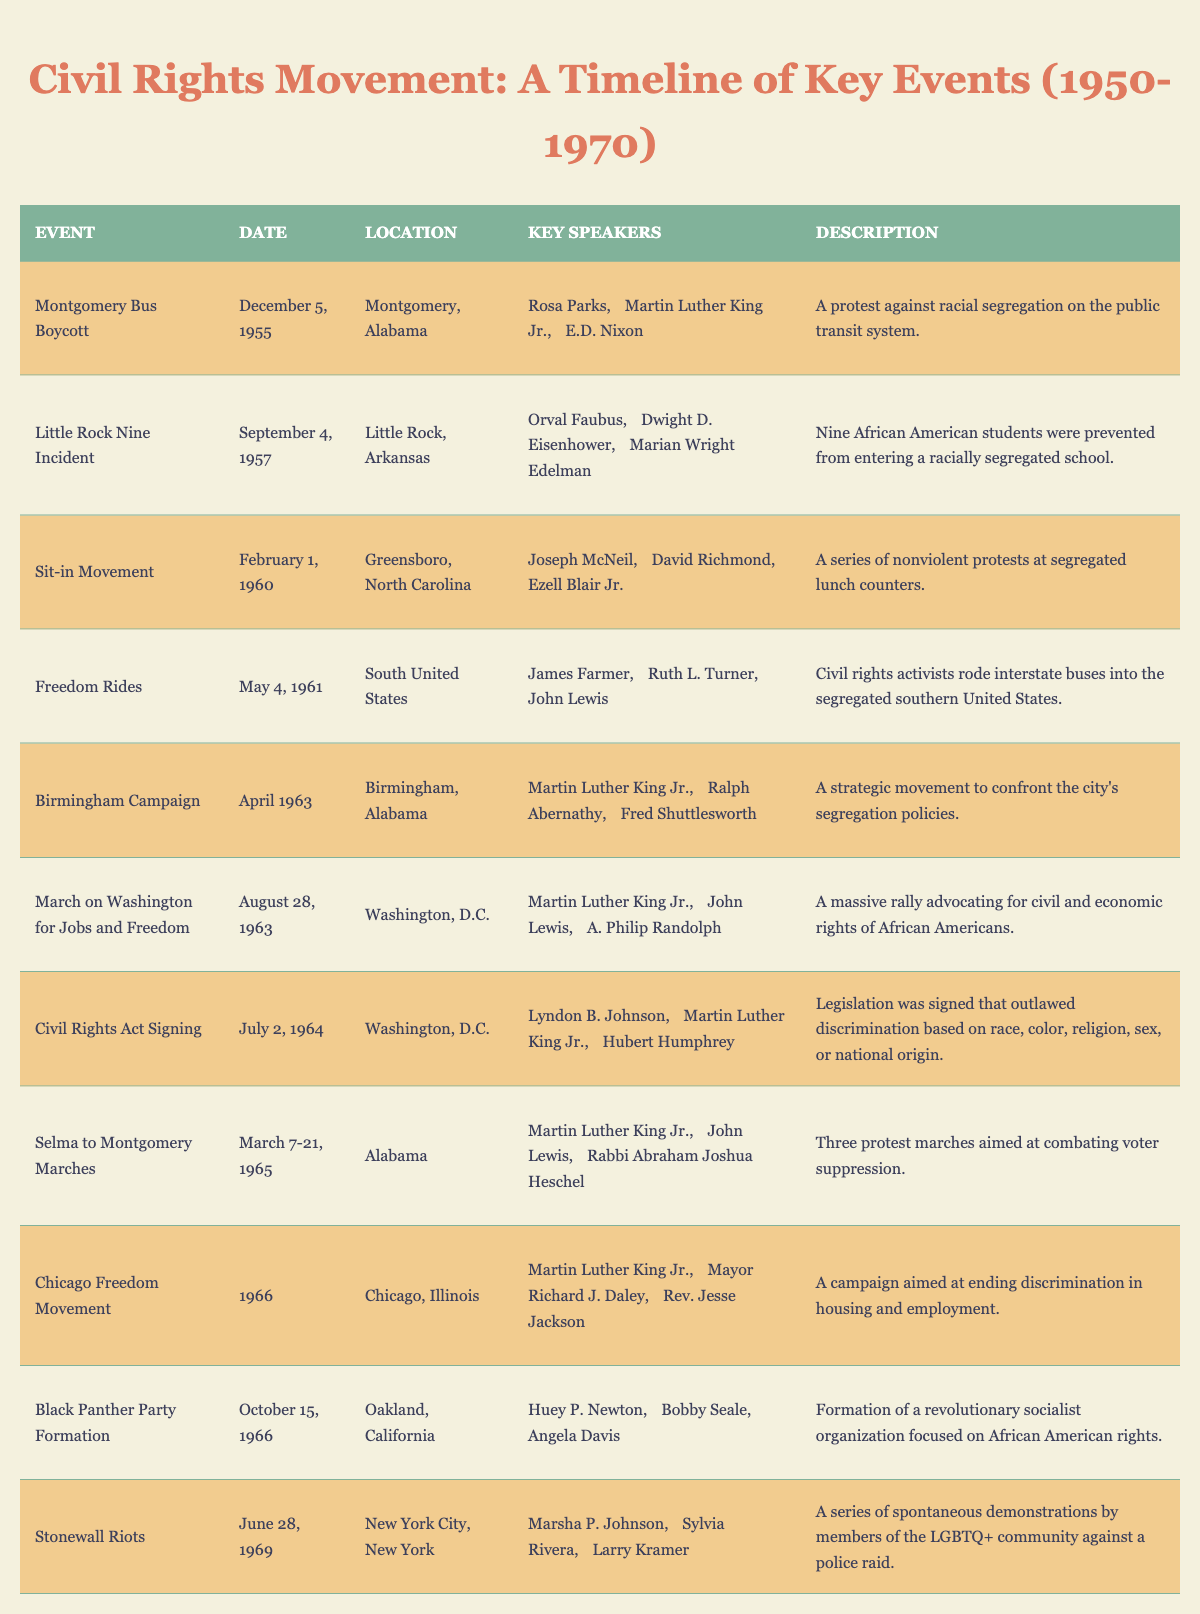What event took place on December 5, 1955? The table indicates that the Montgomery Bus Boycott occurred on December 5, 1955.
Answer: Montgomery Bus Boycott Who were the key speakers at the March on Washington for Jobs and Freedom? The key speakers listed for the March on Washington for Jobs and Freedom are Martin Luther King Jr., John Lewis, and A. Philip Randolph.
Answer: Martin Luther King Jr., John Lewis, A. Philip Randolph Was the Civil Rights Act Signing held in Montgomery, Alabama? The table shows that the Civil Rights Act Signing took place in Washington, D.C., not Montgomery, Alabama.
Answer: No How many events listed in the table occurred in 1963? The events that occurred in 1963 are the Birmingham Campaign and the March on Washington for Jobs and Freedom, making a total of two events.
Answer: 2 List the events where Martin Luther King Jr. was a key speaker. The events with Martin Luther King Jr. as a key speaker include the Montgomery Bus Boycott, Birmingham Campaign, March on Washington for Jobs and Freedom, Civil Rights Act Signing, Selma to Montgomery Marches, and Chicago Freedom Movement.
Answer: 6 events Which event had the smallest number of key speakers listed? The Sit-in Movement and the Stonewall Riots both have three key speakers listed, which is the smallest number seen in the table.
Answer: 3 speakers (tie) What is the location of the Stonewall Riots event? According to the table, the Stonewall Riots occurred in New York City, New York.
Answer: New York City, New York Which two events occurred in 1966, and what were their main focuses? The Chicago Freedom Movement and the Black Panther Party Formation occurred in 1966. The Chicago Freedom Movement focused on ending discrimination in housing and employment, while the Black Panther Party Formation centered on African American rights.
Answer: Chicago Freedom Movement, Black Panther Party Formation What was the description of the Freedom Rides event? The table describes the Freedom Rides as civil rights activists riding interstate buses into the segregated southern United States.
Answer: Civil rights activists rode interstate buses into the segregated southern United States Compare the number of events occurring in the year 1965 versus the number in 1964. In 1965, there was the Selma to Montgomery Marches event, while in 1964, there was the Civil Rights Act Signing event. Thus, each year had one event.
Answer: 1 event each Who were the speakers during the Sit-in Movement? The key speakers during the Sit-in Movement were Joseph McNeil, David Richmond, and Ezell Blair Jr.
Answer: Joseph McNeil, David Richmond, Ezell Blair Jr What is the main theme of the Birmingham Campaign based on its description? The description of the Birmingham Campaign indicates its main theme was to confront the city’s segregation policies.
Answer: Confronting segregation policies How many events listed total occurred in Washington, D.C.? The table shows that three events occurred in Washington, D.C.: the March on Washington for Jobs and Freedom, the Civil Rights Act Signing, and another one involving Martin Luther King Jr. (Civil Rights Act Signing is the one counted).
Answer: 3 events List the key speakers involved in the Selma to Montgomery Marches. The key speakers listed for the Selma to Montgomery Marches are Martin Luther King Jr., John Lewis, and Rabbi Abraham Joshua Heschel.
Answer: Martin Luther King Jr., John Lewis, Rabbi Abraham Joshua Heschel 